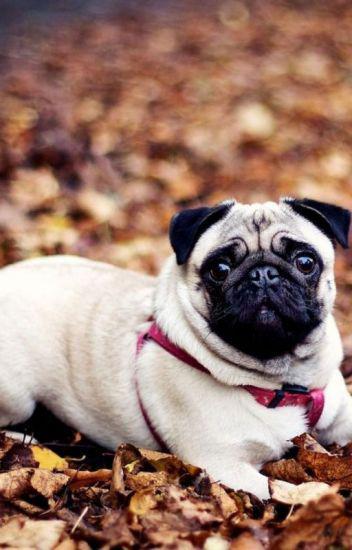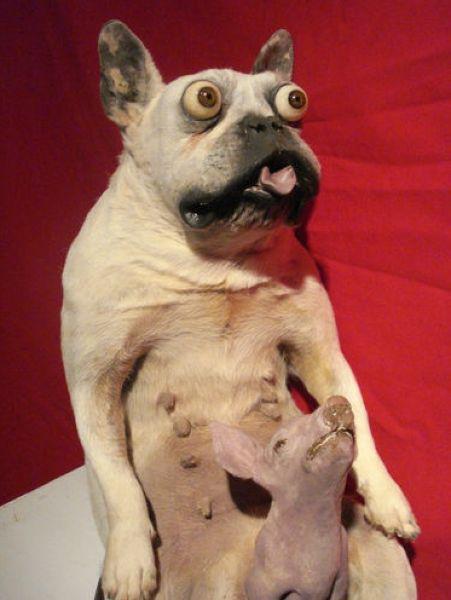The first image is the image on the left, the second image is the image on the right. Considering the images on both sides, is "One of the images features a taxidermy dog." valid? Answer yes or no. Yes. The first image is the image on the left, the second image is the image on the right. Given the left and right images, does the statement "The left image shows one live pug that is not wearing a costume, and the right image includes a flat-faced dog and a pig snout" hold true? Answer yes or no. Yes. 